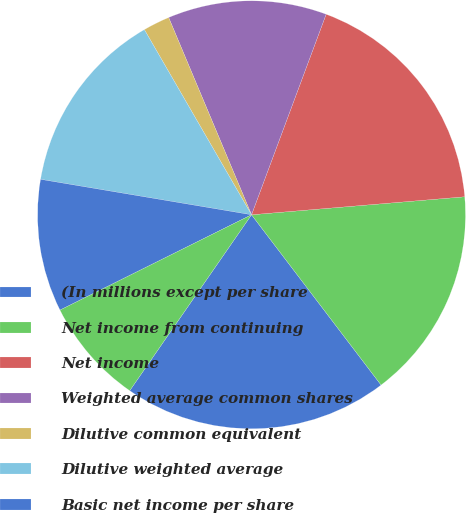Convert chart. <chart><loc_0><loc_0><loc_500><loc_500><pie_chart><fcel>(In millions except per share<fcel>Net income from continuing<fcel>Net income<fcel>Weighted average common shares<fcel>Dilutive common equivalent<fcel>Dilutive weighted average<fcel>Basic net income per share<fcel>Diluted net income per share<nl><fcel>19.99%<fcel>15.99%<fcel>17.99%<fcel>12.0%<fcel>2.02%<fcel>14.0%<fcel>10.0%<fcel>8.01%<nl></chart> 